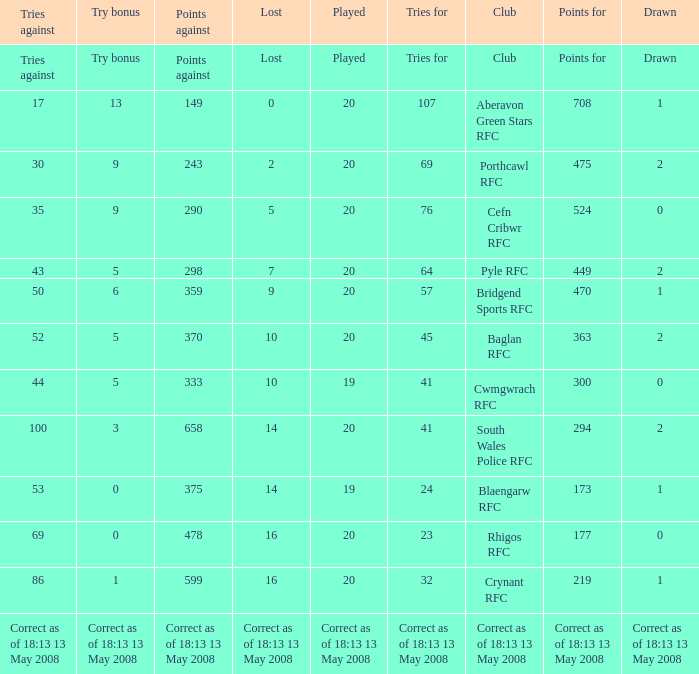What is the points when the try bonus is 1? 219.0. 